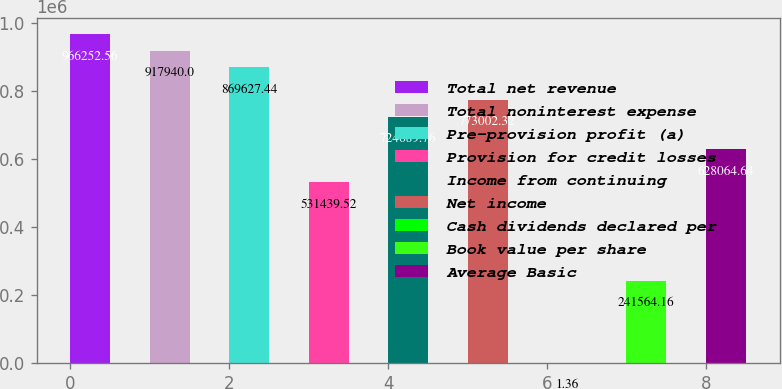Convert chart to OTSL. <chart><loc_0><loc_0><loc_500><loc_500><bar_chart><fcel>Total net revenue<fcel>Total noninterest expense<fcel>Pre-provision profit (a)<fcel>Provision for credit losses<fcel>Income from continuing<fcel>Net income<fcel>Cash dividends declared per<fcel>Book value per share<fcel>Average Basic<nl><fcel>966253<fcel>917940<fcel>869627<fcel>531440<fcel>724690<fcel>773002<fcel>1.36<fcel>241564<fcel>628065<nl></chart> 